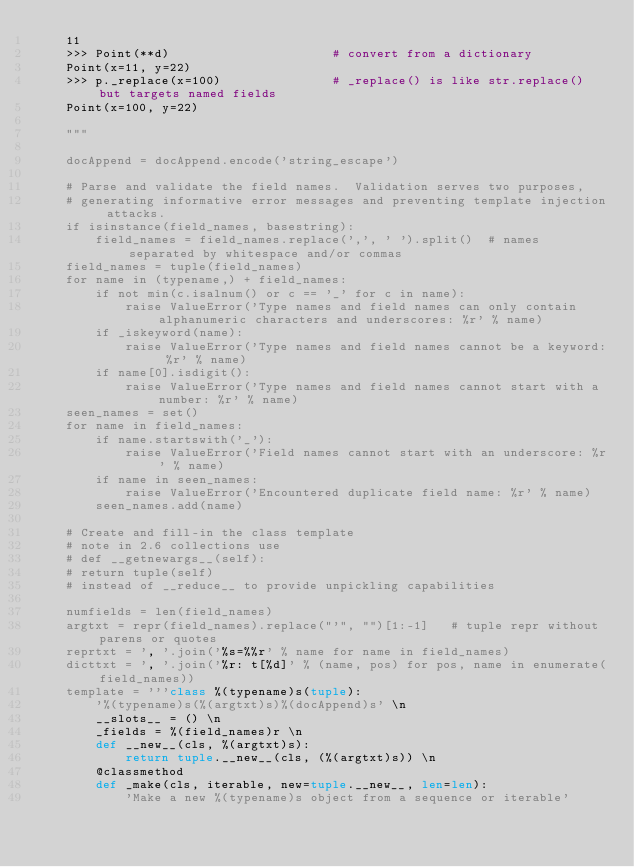<code> <loc_0><loc_0><loc_500><loc_500><_Python_>    11
    >>> Point(**d)                      # convert from a dictionary
    Point(x=11, y=22)
    >>> p._replace(x=100)               # _replace() is like str.replace() but targets named fields
    Point(x=100, y=22)

    """

    docAppend = docAppend.encode('string_escape')

    # Parse and validate the field names.  Validation serves two purposes,
    # generating informative error messages and preventing template injection attacks.
    if isinstance(field_names, basestring):
        field_names = field_names.replace(',', ' ').split()  # names separated by whitespace and/or commas
    field_names = tuple(field_names)
    for name in (typename,) + field_names:
        if not min(c.isalnum() or c == '_' for c in name):
            raise ValueError('Type names and field names can only contain alphanumeric characters and underscores: %r' % name)
        if _iskeyword(name):
            raise ValueError('Type names and field names cannot be a keyword: %r' % name)
        if name[0].isdigit():
            raise ValueError('Type names and field names cannot start with a number: %r' % name)
    seen_names = set()
    for name in field_names:
        if name.startswith('_'):
            raise ValueError('Field names cannot start with an underscore: %r' % name)
        if name in seen_names:
            raise ValueError('Encountered duplicate field name: %r' % name)
        seen_names.add(name)

    # Create and fill-in the class template
    # note in 2.6 collections use
    # def __getnewargs__(self):
    # return tuple(self)
    # instead of __reduce__ to provide unpickling capabilities

    numfields = len(field_names)
    argtxt = repr(field_names).replace("'", "")[1:-1]   # tuple repr without parens or quotes
    reprtxt = ', '.join('%s=%%r' % name for name in field_names)
    dicttxt = ', '.join('%r: t[%d]' % (name, pos) for pos, name in enumerate(field_names))
    template = '''class %(typename)s(tuple):
        '%(typename)s(%(argtxt)s)%(docAppend)s' \n
        __slots__ = () \n
        _fields = %(field_names)r \n
        def __new__(cls, %(argtxt)s):
            return tuple.__new__(cls, (%(argtxt)s)) \n
        @classmethod
        def _make(cls, iterable, new=tuple.__new__, len=len):
            'Make a new %(typename)s object from a sequence or iterable'</code> 